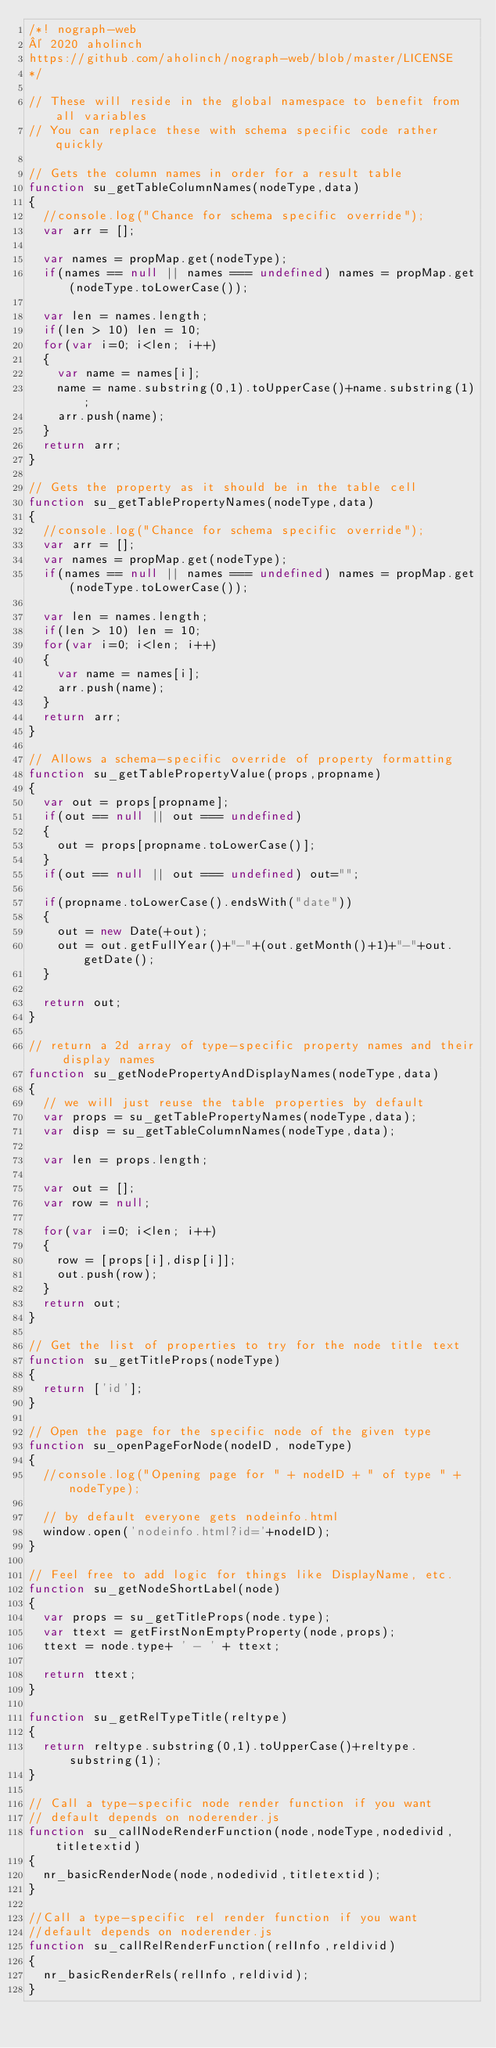<code> <loc_0><loc_0><loc_500><loc_500><_JavaScript_>/*! nograph-web 
© 2020 aholinch 
https://github.com/aholinch/nograph-web/blob/master/LICENSE
*/

// These will reside in the global namespace to benefit from all variables
// You can replace these with schema specific code rather quickly

// Gets the column names in order for a result table
function su_getTableColumnNames(nodeType,data)
{
	//console.log("Chance for schema specific override");
	var arr = [];
	
	var names = propMap.get(nodeType);
	if(names == null || names === undefined) names = propMap.get(nodeType.toLowerCase());
	
	var len = names.length;
	if(len > 10) len = 10;
	for(var i=0; i<len; i++)
	{
		var name = names[i];
		name = name.substring(0,1).toUpperCase()+name.substring(1);
		arr.push(name);
	}
	return arr;
}

// Gets the property as it should be in the table cell
function su_getTablePropertyNames(nodeType,data)
{
	//console.log("Chance for schema specific override");
	var arr = [];
	var names = propMap.get(nodeType);
	if(names == null || names === undefined) names = propMap.get(nodeType.toLowerCase());
	
	var len = names.length;
	if(len > 10) len = 10;
	for(var i=0; i<len; i++)
	{
		var name = names[i];
		arr.push(name);
	}
	return arr;	
}

// Allows a schema-specific override of property formatting
function su_getTablePropertyValue(props,propname)
{
	var out = props[propname];
	if(out == null || out === undefined)
	{
		out = props[propname.toLowerCase()];
	}
	if(out == null || out === undefined) out="";

	if(propname.toLowerCase().endsWith("date"))
	{
		out = new Date(+out);
		out = out.getFullYear()+"-"+(out.getMonth()+1)+"-"+out.getDate();
	}
	
	return out;
}

// return a 2d array of type-specific property names and their display names
function su_getNodePropertyAndDisplayNames(nodeType,data)
{
	// we will just reuse the table properties by default
	var props = su_getTablePropertyNames(nodeType,data);
	var disp = su_getTableColumnNames(nodeType,data);
	
	var len = props.length;
	
	var out = [];
	var row = null;
	
	for(var i=0; i<len; i++)
	{
		row = [props[i],disp[i]];
		out.push(row);
	}
	return out;
}

// Get the list of properties to try for the node title text
function su_getTitleProps(nodeType)
{
	return ['id'];
}

// Open the page for the specific node of the given type
function su_openPageForNode(nodeID, nodeType)
{
	//console.log("Opening page for " + nodeID + " of type " + nodeType);
	
	// by default everyone gets nodeinfo.html
	window.open('nodeinfo.html?id='+nodeID);
}

// Feel free to add logic for things like DisplayName, etc.
function su_getNodeShortLabel(node)
{
	var props = su_getTitleProps(node.type);
	var ttext = getFirstNonEmptyProperty(node,props);
	ttext = node.type+ ' - ' + ttext;
	
	return ttext;
}

function su_getRelTypeTitle(reltype)
{
	return reltype.substring(0,1).toUpperCase()+reltype.substring(1);
}

// Call a type-specific node render function if you want
// default depends on noderender.js
function su_callNodeRenderFunction(node,nodeType,nodedivid,titletextid)
{
	nr_basicRenderNode(node,nodedivid,titletextid);
}

//Call a type-specific rel render function if you want
//default depends on noderender.js
function su_callRelRenderFunction(relInfo,reldivid)
{
	nr_basicRenderRels(relInfo,reldivid);
}</code> 